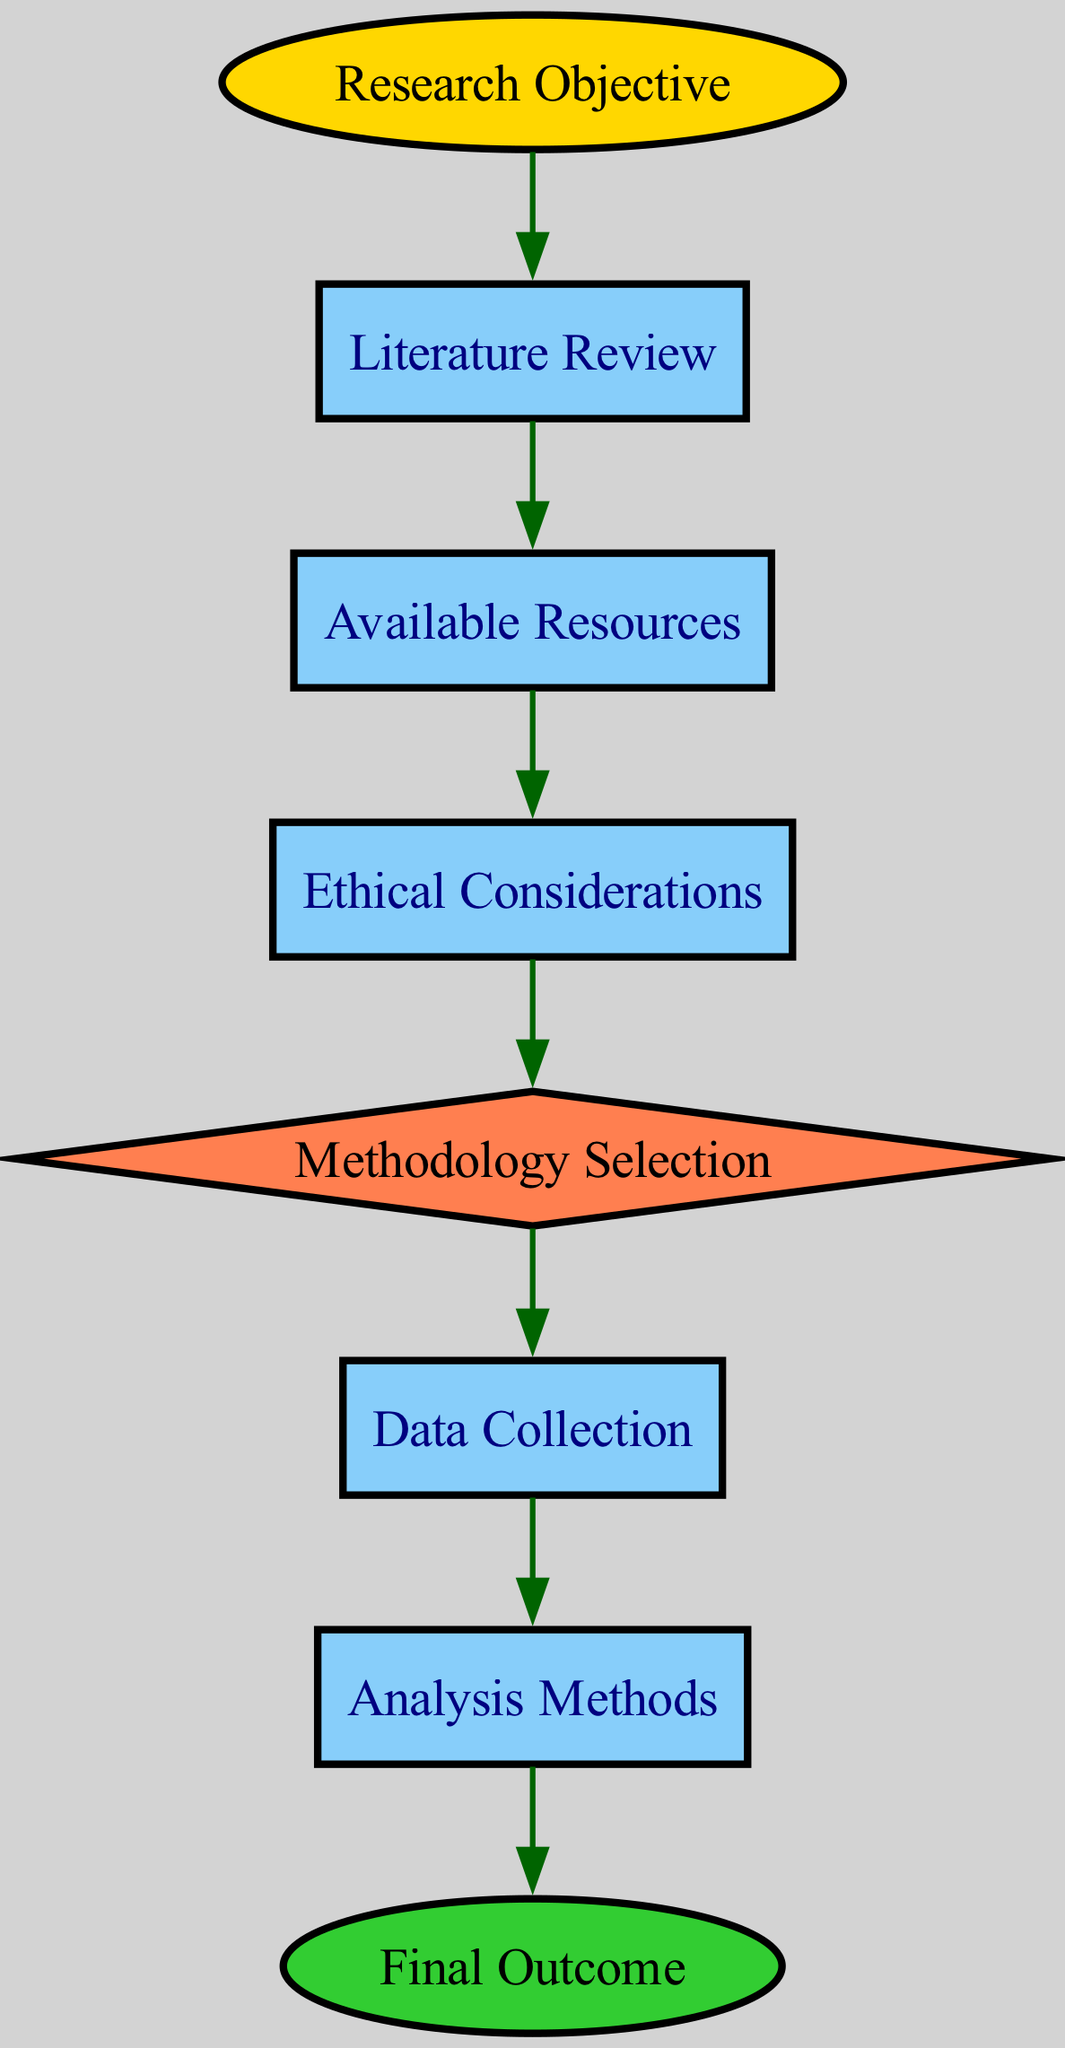What is the total number of nodes in the diagram? There are eight nodes visible in the diagram: Research Objective, Literature Review, Available Resources, Ethical Considerations, Methodology Selection, Data Collection, Analysis Methods, and Final Outcome. Counting them gives a total of 8.
Answer: 8 Which node represents the final outcome of the research methodology process? The final outcome node is labeled "Final Outcome" and is designed as an ellipse in green, which signifies that it is the last step of the decision-making flow.
Answer: Final Outcome What shape is used to represent the Methodology Selection node? In the diagram, the Methodology Selection node is represented by a diamond shape, which is commonly used to indicate decision points in flowcharts.
Answer: Diamond Which node directly precedes Data Collection in the flow? The node that directly leads to Data Collection is Methodology Selection, as seen in the directed edge connecting these two nodes.
Answer: Methodology Selection What is the relationship between Available Resources and Ethical Considerations? The relationship is that Available Resources leads into Ethical Considerations, indicating that once the available resources are assessed, ethical considerations need to be addressed next in the process.
Answer: Available Resources → Ethical Considerations How many edges are used to connect the nodes in the diagram? There are seven edges in total that connect the different nodes in the diagram, showing the flow of the decision-making process from research objective to final outcome.
Answer: 7 What does the edge connecting Ethical Considerations to Methodology Selection indicate? The edge implies that the ethical considerations made must be evaluated before the actual methodology selection, indicating it's a necessary prerequisite in the decision-making process.
Answer: Necessity What criterion is evaluated after Literature Review? After the Literature Review, the next criterion evaluated is Available Resources, noting that the literature review identifies the context for assessing what resources are at hand.
Answer: Available Resources In what order do nodes represent the decision-making process? The ordered sequence of nodes is: Research Objective → Literature Review → Available Resources → Ethical Considerations → Methodology Selection → Data Collection → Analysis Methods → Final Outcome, indicating a linear progression through the decision-making stages.
Answer: Sequential Order 